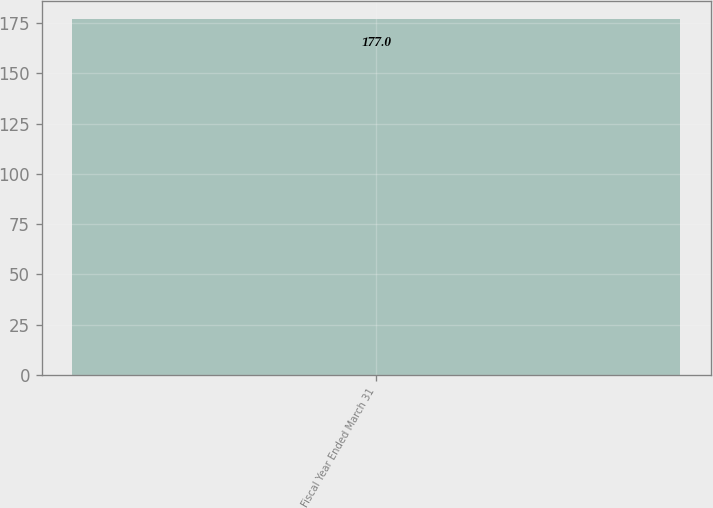Convert chart. <chart><loc_0><loc_0><loc_500><loc_500><bar_chart><fcel>Fiscal Year Ended March 31<nl><fcel>177<nl></chart> 